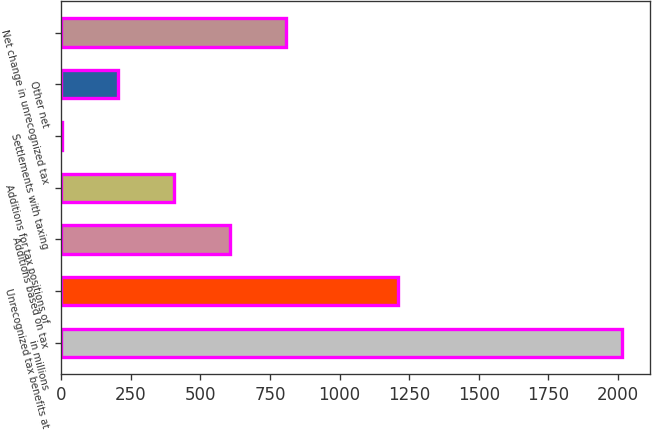<chart> <loc_0><loc_0><loc_500><loc_500><bar_chart><fcel>in millions<fcel>Unrecognized tax benefits at<fcel>Additions based on tax<fcel>Additions for tax positions of<fcel>Settlements with taxing<fcel>Other net<fcel>Net change in unrecognized tax<nl><fcel>2013<fcel>1208.2<fcel>604.6<fcel>403.4<fcel>1<fcel>202.2<fcel>805.8<nl></chart> 